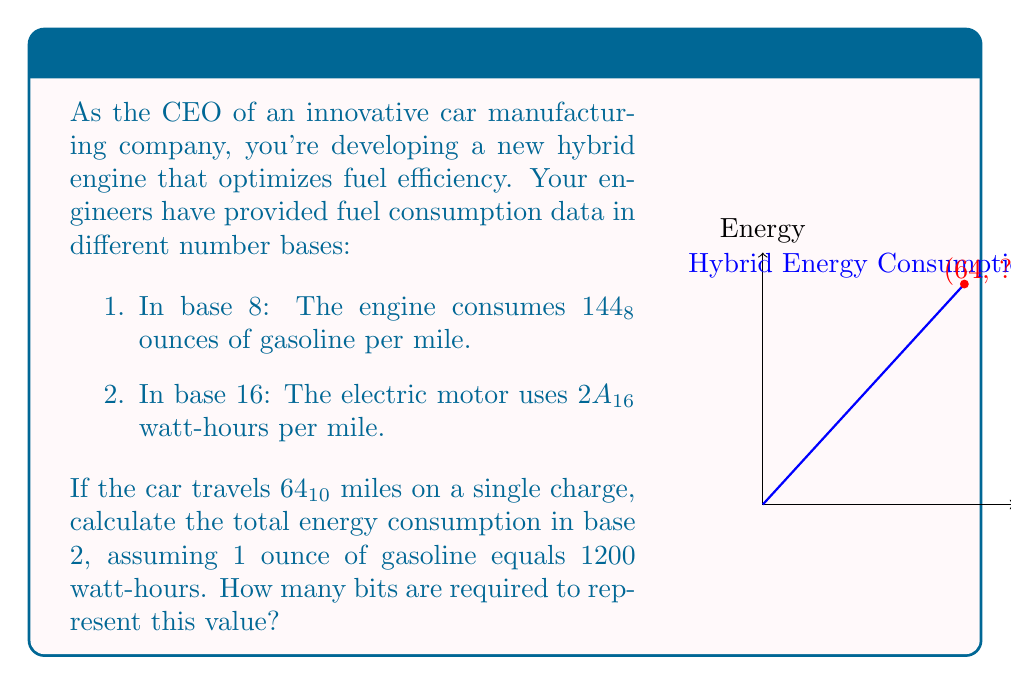Can you solve this math problem? Let's approach this step-by-step:

1) First, convert the gasoline consumption from base 8 to base 10:
   $144_8 = 1 \times 8^2 + 4 \times 8^1 + 4 \times 8^0 = 64 + 32 + 4 = 100_{10}$ ounces per mile

2) Convert the electric consumption from base 16 to base 10:
   $2A_{16} = 2 \times 16^1 + 10 \times 16^0 = 32 + 10 = 42_{10}$ watt-hours per mile

3) Calculate total gasoline consumption for 64 miles:
   $100 \times 64 = 6400$ ounces

4) Convert gasoline to watt-hours:
   $6400 \times 1200 = 7,680,000$ watt-hours

5) Calculate total electric consumption for 64 miles:
   $42 \times 64 = 2,688$ watt-hours

6) Sum up total energy consumption:
   $7,680,000 + 2,688 = 7,682,688$ watt-hours

7) Convert 7,682,688 to base 2:
   $7,682,688_{10} = 11101001001000000000000_2$

8) Count the bits in the binary representation:
   The binary number has 23 bits.
Answer: $11101001001000000000000_2$, 23 bits 